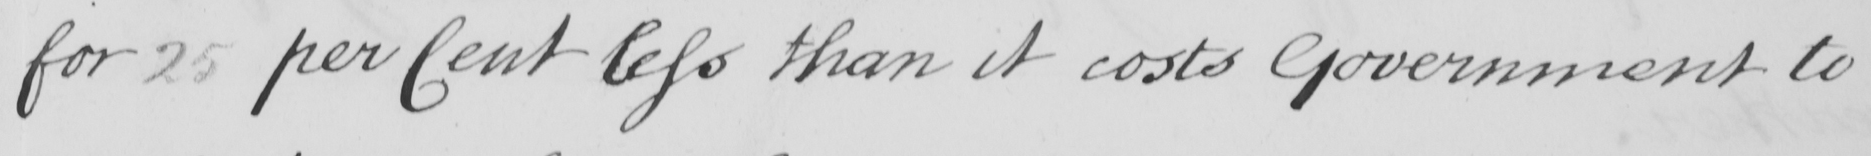What is written in this line of handwriting? for 25 per Cent less than it costs Government to 